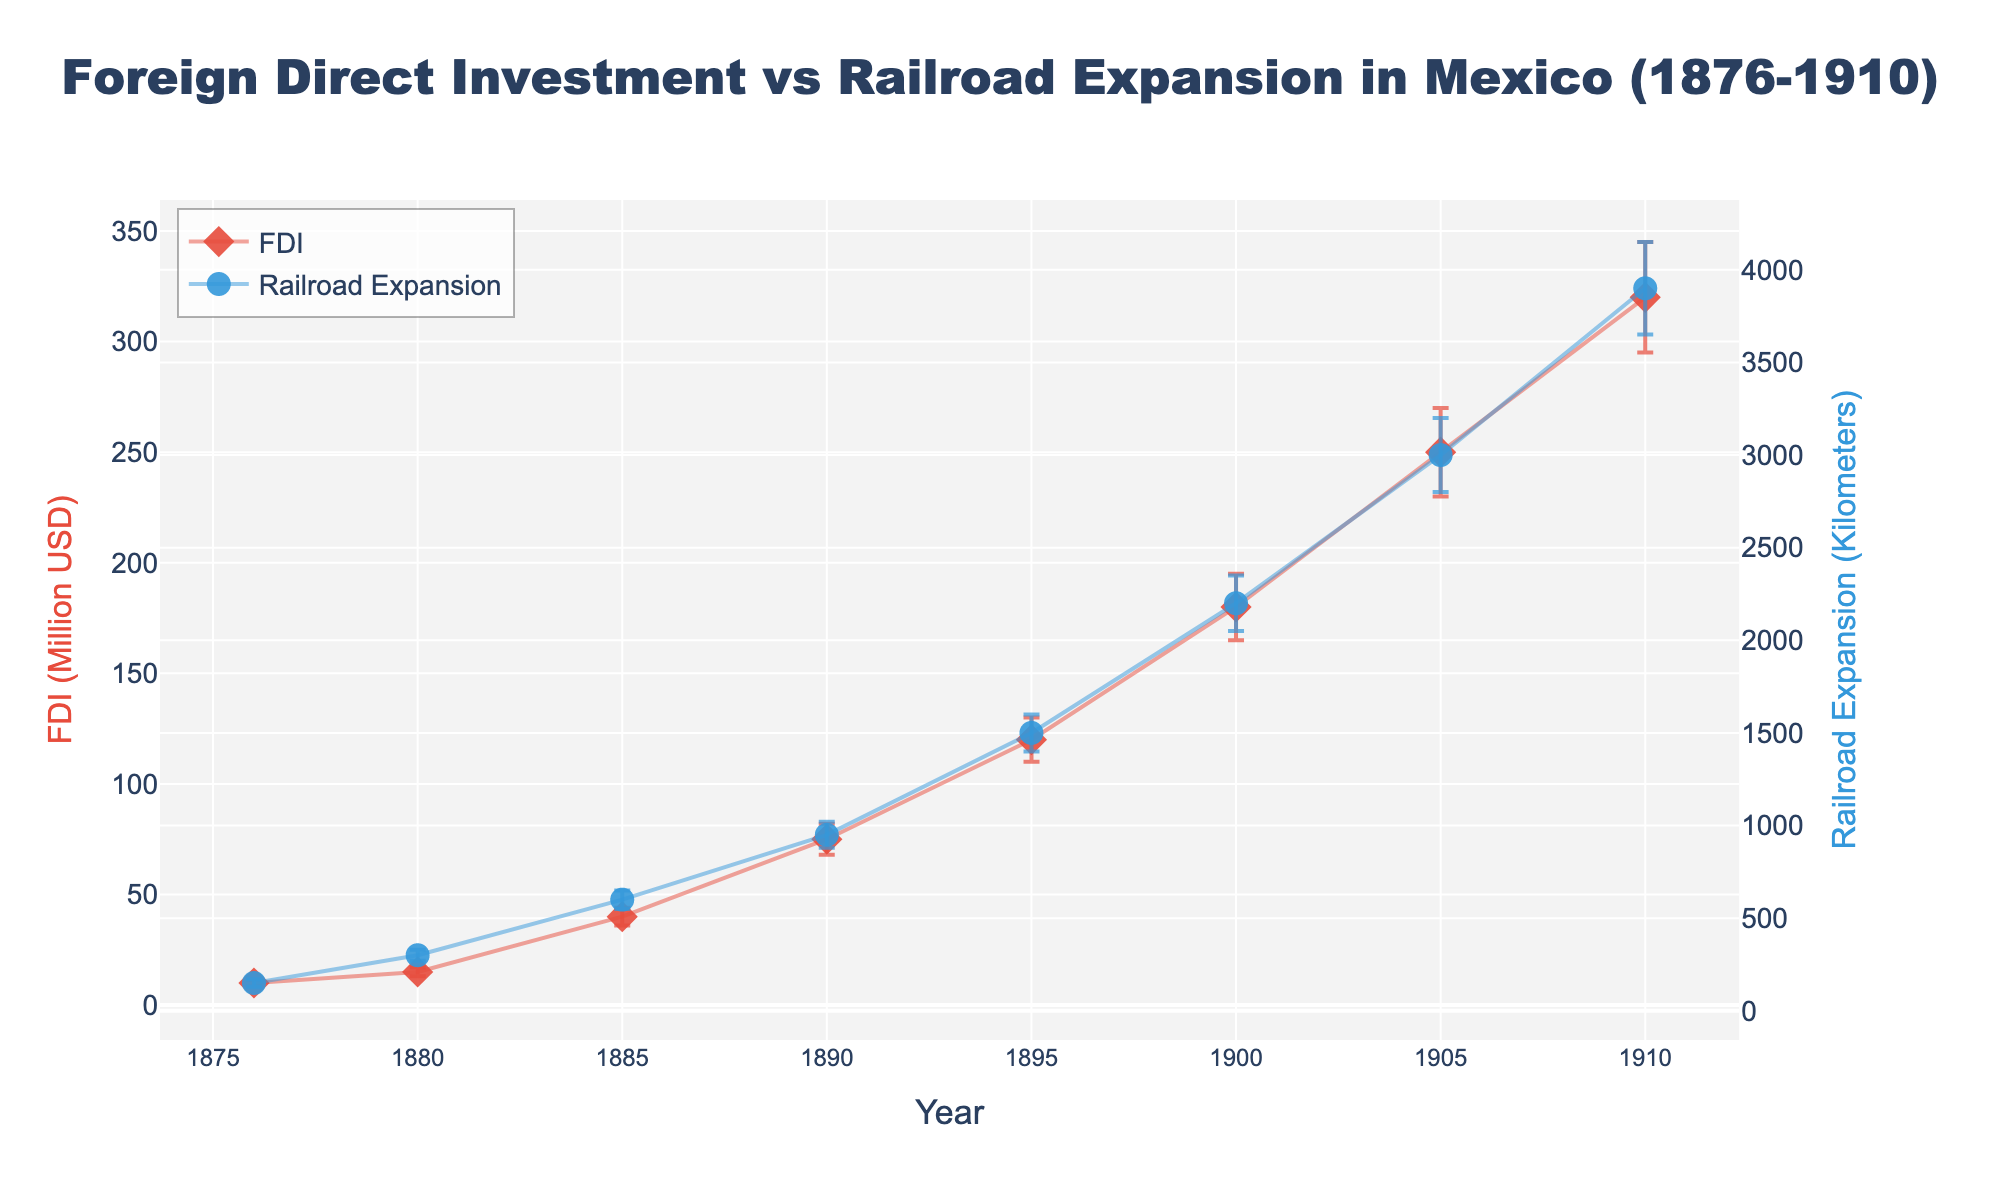which years are plotted on the x-axis? The x-axis shows the years in the data set.
Answer: 1876, 1880, 1885, 1890, 1895, 1900, 1905, 1910 what's the title of the plot? The title is located at the top center of the plot.
Answer: Foreign Direct Investment vs Railroad Expansion in Mexico (1876-1910) how many primary y-axes are used in this plot? Examine the number of y-axis titles on the left and right sides of the plot.
Answer: 2 which variable has larger uncertainty, FDI or railroad expansion in 1910? Compare the error bars for FDI and railroad expansion in 1910.
Answer: Railroad Expansion how does foreign direct investment (FDI) change from 1876 to 1910? Look at the trend line for FDI from 1876 to 1910.
Answer: It increases what is the approximate FDI (in million USD) around 1885? Check the Y-value for FDI in 1885.
Answer: 40 how does the pattern of uncertainty change over time for railroad expansion? Observe the length of the error bars for railroad expansion as you move from left to right.
Answer: It increases between which years does railroad expansion experience the greatest growth? Identify the period with the steepest slope in the railroad expansion line.
Answer: 1890-1895 which year shows the highest railroad expansion and what is the value? Find the point with the highest Y-value on the railroad expansion curve.
Answer: 1910, 3900 kilometers compare the slopes of FDI and railroad expansion between 1890 and 1900. which slope is steeper? Calculate the difference in FDI and railroad expansion between 1890 and 1900 and compare slopes.
Answer: Railroad Expansion 